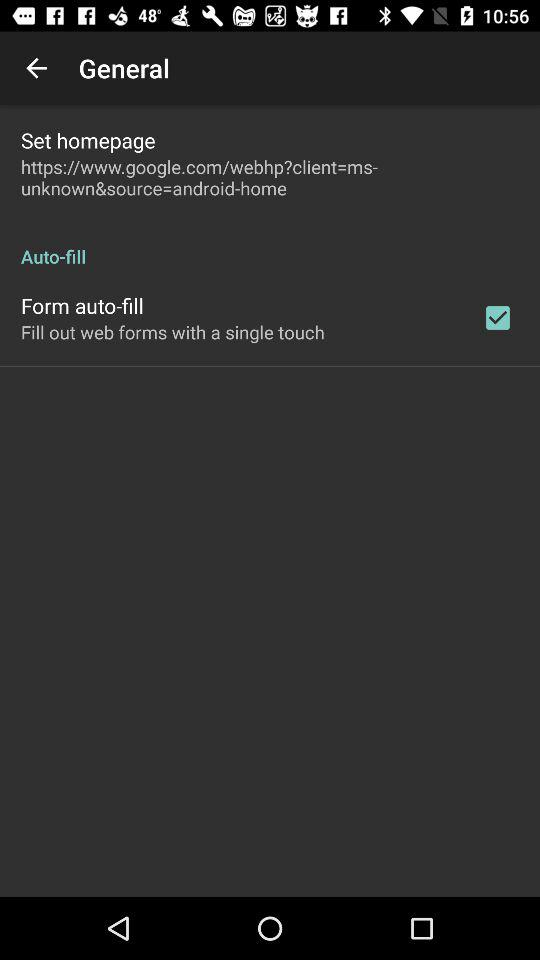What is the status of "Set homepage"?
When the provided information is insufficient, respond with <no answer>. <no answer> 